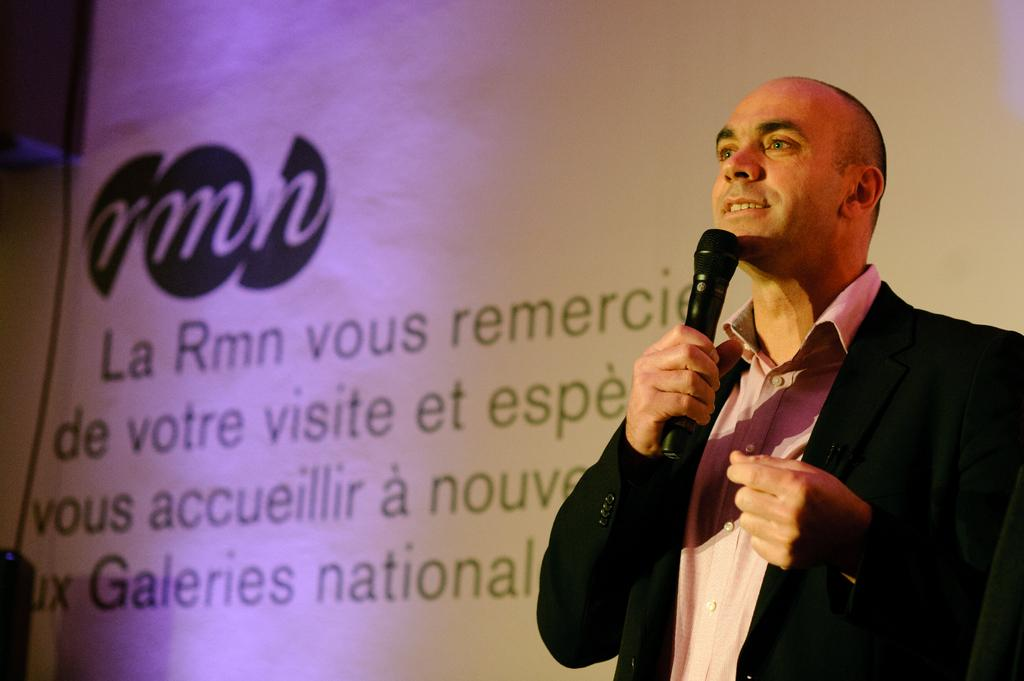What is the main subject of the image? The main subject of the image is a man. What is the man doing in the image? The man is standing and holding a mic in his hand. What is the man wearing in the image? The man is wearing a coat. What is the man's facial expression in the image? The man is smiling. What can be seen in the background of the image? There is a screen in the background of the image. What is displayed on the screen in the image? The screen has sentences on it. What type of dirt can be seen on the man's shoes in the image? There is no dirt visible on the man's shoes in the image. What type of root is growing near the man in the image? There are no roots present in the image. 